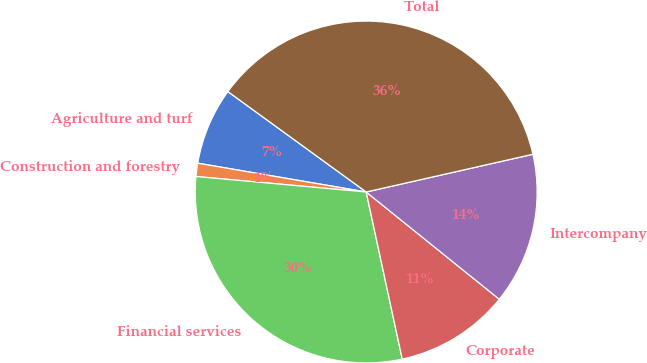Convert chart to OTSL. <chart><loc_0><loc_0><loc_500><loc_500><pie_chart><fcel>Agriculture and turf<fcel>Construction and forestry<fcel>Financial services<fcel>Corporate<fcel>Intercompany<fcel>Total<nl><fcel>7.3%<fcel>1.25%<fcel>29.83%<fcel>10.82%<fcel>14.34%<fcel>36.46%<nl></chart> 